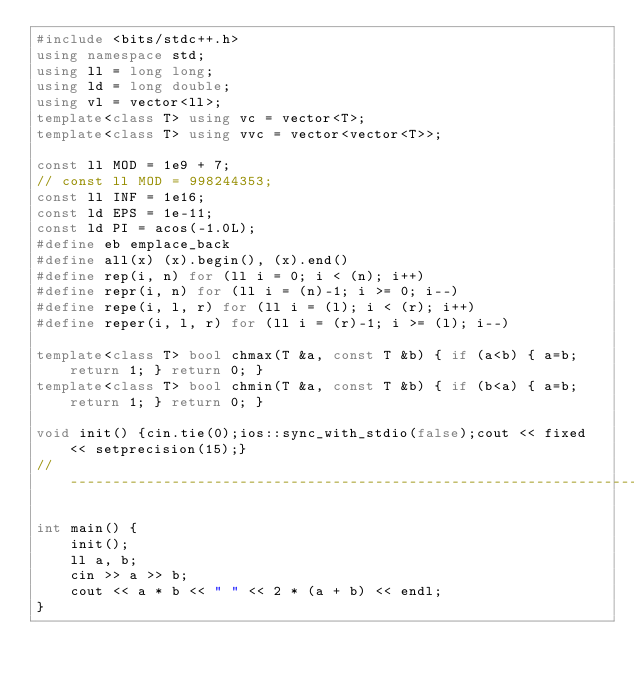Convert code to text. <code><loc_0><loc_0><loc_500><loc_500><_C++_>#include <bits/stdc++.h>
using namespace std;
using ll = long long;
using ld = long double;
using vl = vector<ll>;
template<class T> using vc = vector<T>;
template<class T> using vvc = vector<vector<T>>;

const ll MOD = 1e9 + 7;
// const ll MOD = 998244353;
const ll INF = 1e16;
const ld EPS = 1e-11;
const ld PI = acos(-1.0L);
#define eb emplace_back
#define all(x) (x).begin(), (x).end()
#define rep(i, n) for (ll i = 0; i < (n); i++)
#define repr(i, n) for (ll i = (n)-1; i >= 0; i--)
#define repe(i, l, r) for (ll i = (l); i < (r); i++)
#define reper(i, l, r) for (ll i = (r)-1; i >= (l); i--)

template<class T> bool chmax(T &a, const T &b) { if (a<b) { a=b; return 1; } return 0; }
template<class T> bool chmin(T &a, const T &b) { if (b<a) { a=b; return 1; } return 0; }

void init() {cin.tie(0);ios::sync_with_stdio(false);cout << fixed << setprecision(15);}
//--------------------------------------------------------------------------------//

int main() {
    init();
    ll a, b;
    cin >> a >> b;
    cout << a * b << " " << 2 * (a + b) << endl;
}
</code> 